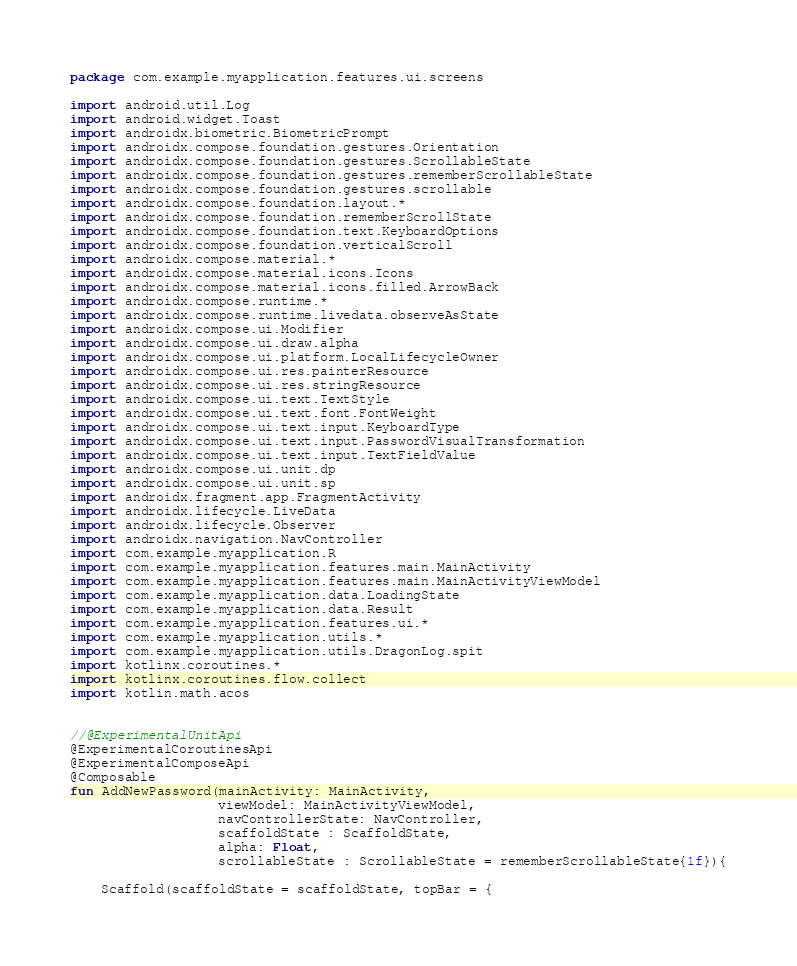<code> <loc_0><loc_0><loc_500><loc_500><_Kotlin_>package com.example.myapplication.features.ui.screens

import android.util.Log
import android.widget.Toast
import androidx.biometric.BiometricPrompt
import androidx.compose.foundation.gestures.Orientation
import androidx.compose.foundation.gestures.ScrollableState
import androidx.compose.foundation.gestures.rememberScrollableState
import androidx.compose.foundation.gestures.scrollable
import androidx.compose.foundation.layout.*
import androidx.compose.foundation.rememberScrollState
import androidx.compose.foundation.text.KeyboardOptions
import androidx.compose.foundation.verticalScroll
import androidx.compose.material.*
import androidx.compose.material.icons.Icons
import androidx.compose.material.icons.filled.ArrowBack
import androidx.compose.runtime.*
import androidx.compose.runtime.livedata.observeAsState
import androidx.compose.ui.Modifier
import androidx.compose.ui.draw.alpha
import androidx.compose.ui.platform.LocalLifecycleOwner
import androidx.compose.ui.res.painterResource
import androidx.compose.ui.res.stringResource
import androidx.compose.ui.text.TextStyle
import androidx.compose.ui.text.font.FontWeight
import androidx.compose.ui.text.input.KeyboardType
import androidx.compose.ui.text.input.PasswordVisualTransformation
import androidx.compose.ui.text.input.TextFieldValue
import androidx.compose.ui.unit.dp
import androidx.compose.ui.unit.sp
import androidx.fragment.app.FragmentActivity
import androidx.lifecycle.LiveData
import androidx.lifecycle.Observer
import androidx.navigation.NavController
import com.example.myapplication.R
import com.example.myapplication.features.main.MainActivity
import com.example.myapplication.features.main.MainActivityViewModel
import com.example.myapplication.data.LoadingState
import com.example.myapplication.data.Result
import com.example.myapplication.features.ui.*
import com.example.myapplication.utils.*
import com.example.myapplication.utils.DragonLog.spit
import kotlinx.coroutines.*
import kotlinx.coroutines.flow.collect
import kotlin.math.acos


//@ExperimentalUnitApi
@ExperimentalCoroutinesApi
@ExperimentalComposeApi
@Composable
fun AddNewPassword(mainActivity: MainActivity,
                   viewModel: MainActivityViewModel,
                   navControllerState: NavController,
                   scaffoldState : ScaffoldState,
                   alpha: Float,
                   scrollableState : ScrollableState = rememberScrollableState{1f}){

    Scaffold(scaffoldState = scaffoldState, topBar = {</code> 